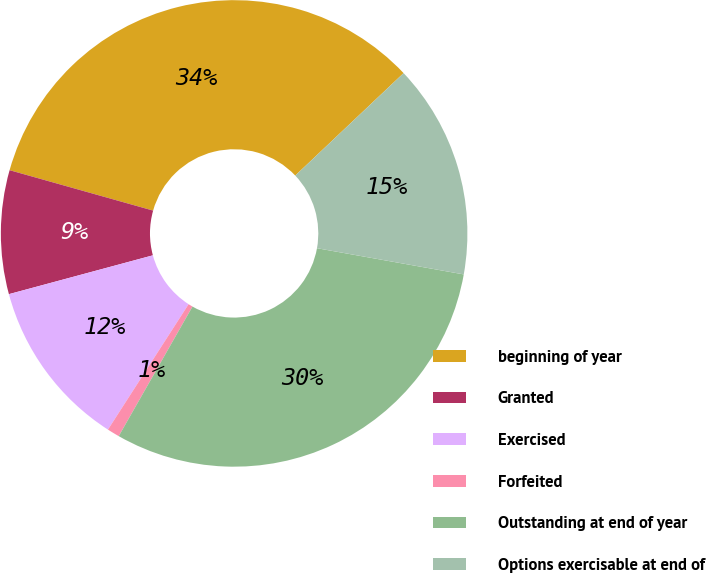Convert chart. <chart><loc_0><loc_0><loc_500><loc_500><pie_chart><fcel>beginning of year<fcel>Granted<fcel>Exercised<fcel>Forfeited<fcel>Outstanding at end of year<fcel>Options exercisable at end of<nl><fcel>33.57%<fcel>8.56%<fcel>11.71%<fcel>0.86%<fcel>30.42%<fcel>14.87%<nl></chart> 